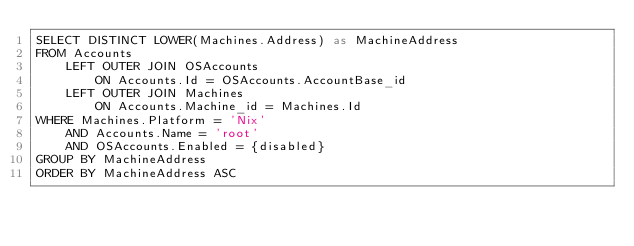<code> <loc_0><loc_0><loc_500><loc_500><_SQL_>SELECT DISTINCT LOWER(Machines.Address) as MachineAddress
FROM Accounts
	LEFT OUTER JOIN OSAccounts
		ON Accounts.Id = OSAccounts.AccountBase_id
	LEFT OUTER JOIN Machines
		ON Accounts.Machine_id = Machines.Id
WHERE Machines.Platform = 'Nix'
	AND Accounts.Name = 'root'
	AND OSAccounts.Enabled = {disabled}
GROUP BY MachineAddress
ORDER BY MachineAddress ASC</code> 